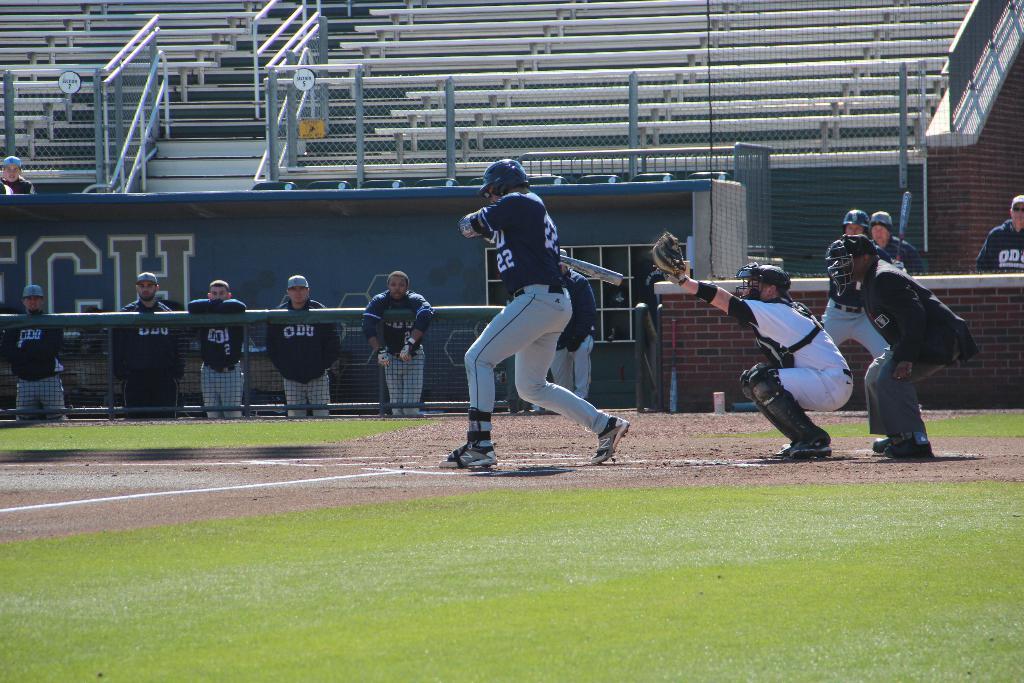What jersey number is the man currently batting wearing?
Offer a terse response. 22. What letters are visible on the wall of the dugout?
Your response must be concise. Ch. 